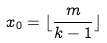Convert formula to latex. <formula><loc_0><loc_0><loc_500><loc_500>x _ { 0 } = \lfloor \frac { m } { k - 1 } \rfloor</formula> 